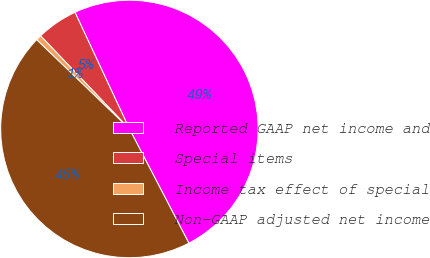Convert chart. <chart><loc_0><loc_0><loc_500><loc_500><pie_chart><fcel>Reported GAAP net income and<fcel>Special items<fcel>Income tax effect of special<fcel>Non-GAAP adjusted net income<nl><fcel>49.31%<fcel>5.17%<fcel>0.69%<fcel>44.83%<nl></chart> 